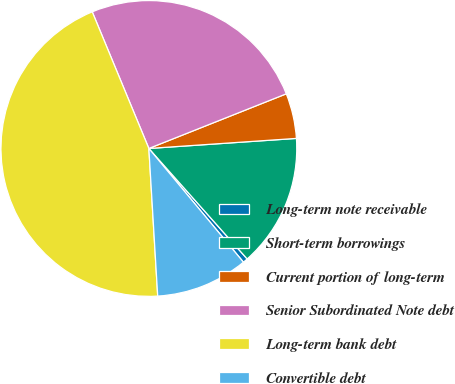Convert chart. <chart><loc_0><loc_0><loc_500><loc_500><pie_chart><fcel>Long-term note receivable<fcel>Short-term borrowings<fcel>Current portion of long-term<fcel>Senior Subordinated Note debt<fcel>Long-term bank debt<fcel>Convertible debt<nl><fcel>0.53%<fcel>14.51%<fcel>4.94%<fcel>25.23%<fcel>44.7%<fcel>10.09%<nl></chart> 